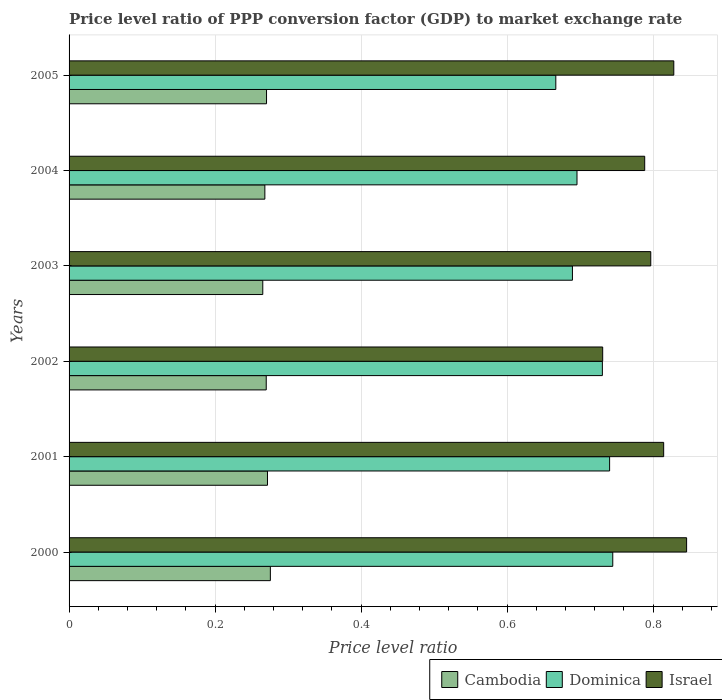How many groups of bars are there?
Ensure brevity in your answer.  6. Are the number of bars per tick equal to the number of legend labels?
Provide a succinct answer. Yes. Are the number of bars on each tick of the Y-axis equal?
Your response must be concise. Yes. How many bars are there on the 2nd tick from the top?
Provide a succinct answer. 3. How many bars are there on the 6th tick from the bottom?
Make the answer very short. 3. What is the price level ratio in Cambodia in 2000?
Provide a succinct answer. 0.28. Across all years, what is the maximum price level ratio in Dominica?
Offer a terse response. 0.74. Across all years, what is the minimum price level ratio in Cambodia?
Your answer should be compact. 0.27. In which year was the price level ratio in Cambodia minimum?
Your response must be concise. 2003. What is the total price level ratio in Dominica in the graph?
Keep it short and to the point. 4.27. What is the difference between the price level ratio in Dominica in 2001 and that in 2002?
Your answer should be very brief. 0.01. What is the difference between the price level ratio in Israel in 2001 and the price level ratio in Dominica in 2002?
Ensure brevity in your answer.  0.08. What is the average price level ratio in Israel per year?
Offer a very short reply. 0.8. In the year 2001, what is the difference between the price level ratio in Cambodia and price level ratio in Dominica?
Your answer should be compact. -0.47. In how many years, is the price level ratio in Israel greater than 0.56 ?
Make the answer very short. 6. What is the ratio of the price level ratio in Israel in 2001 to that in 2004?
Give a very brief answer. 1.03. What is the difference between the highest and the second highest price level ratio in Israel?
Give a very brief answer. 0.02. What is the difference between the highest and the lowest price level ratio in Israel?
Give a very brief answer. 0.11. In how many years, is the price level ratio in Israel greater than the average price level ratio in Israel taken over all years?
Your answer should be very brief. 3. Is it the case that in every year, the sum of the price level ratio in Israel and price level ratio in Cambodia is greater than the price level ratio in Dominica?
Your answer should be very brief. Yes. How many bars are there?
Your answer should be very brief. 18. Are all the bars in the graph horizontal?
Your response must be concise. Yes. How many years are there in the graph?
Offer a terse response. 6. What is the difference between two consecutive major ticks on the X-axis?
Your response must be concise. 0.2. Are the values on the major ticks of X-axis written in scientific E-notation?
Your answer should be very brief. No. Does the graph contain grids?
Keep it short and to the point. Yes. Where does the legend appear in the graph?
Offer a terse response. Bottom right. How many legend labels are there?
Ensure brevity in your answer.  3. What is the title of the graph?
Give a very brief answer. Price level ratio of PPP conversion factor (GDP) to market exchange rate. Does "Tunisia" appear as one of the legend labels in the graph?
Offer a terse response. No. What is the label or title of the X-axis?
Ensure brevity in your answer.  Price level ratio. What is the Price level ratio of Cambodia in 2000?
Keep it short and to the point. 0.28. What is the Price level ratio in Dominica in 2000?
Your response must be concise. 0.74. What is the Price level ratio in Israel in 2000?
Make the answer very short. 0.85. What is the Price level ratio of Cambodia in 2001?
Make the answer very short. 0.27. What is the Price level ratio of Dominica in 2001?
Provide a succinct answer. 0.74. What is the Price level ratio of Israel in 2001?
Make the answer very short. 0.81. What is the Price level ratio of Cambodia in 2002?
Your response must be concise. 0.27. What is the Price level ratio in Dominica in 2002?
Ensure brevity in your answer.  0.73. What is the Price level ratio of Israel in 2002?
Provide a short and direct response. 0.73. What is the Price level ratio in Cambodia in 2003?
Offer a terse response. 0.27. What is the Price level ratio in Dominica in 2003?
Ensure brevity in your answer.  0.69. What is the Price level ratio in Israel in 2003?
Provide a succinct answer. 0.8. What is the Price level ratio of Cambodia in 2004?
Offer a terse response. 0.27. What is the Price level ratio in Dominica in 2004?
Provide a succinct answer. 0.7. What is the Price level ratio in Israel in 2004?
Your response must be concise. 0.79. What is the Price level ratio of Cambodia in 2005?
Your answer should be compact. 0.27. What is the Price level ratio of Dominica in 2005?
Offer a very short reply. 0.67. What is the Price level ratio of Israel in 2005?
Your answer should be compact. 0.83. Across all years, what is the maximum Price level ratio in Cambodia?
Offer a very short reply. 0.28. Across all years, what is the maximum Price level ratio of Dominica?
Provide a succinct answer. 0.74. Across all years, what is the maximum Price level ratio in Israel?
Make the answer very short. 0.85. Across all years, what is the minimum Price level ratio in Cambodia?
Ensure brevity in your answer.  0.27. Across all years, what is the minimum Price level ratio in Dominica?
Provide a succinct answer. 0.67. Across all years, what is the minimum Price level ratio of Israel?
Keep it short and to the point. 0.73. What is the total Price level ratio in Cambodia in the graph?
Your response must be concise. 1.62. What is the total Price level ratio in Dominica in the graph?
Your answer should be compact. 4.27. What is the total Price level ratio in Israel in the graph?
Your answer should be compact. 4.8. What is the difference between the Price level ratio of Cambodia in 2000 and that in 2001?
Offer a terse response. 0. What is the difference between the Price level ratio of Dominica in 2000 and that in 2001?
Offer a very short reply. 0. What is the difference between the Price level ratio of Israel in 2000 and that in 2001?
Offer a very short reply. 0.03. What is the difference between the Price level ratio of Cambodia in 2000 and that in 2002?
Your answer should be compact. 0.01. What is the difference between the Price level ratio in Dominica in 2000 and that in 2002?
Make the answer very short. 0.01. What is the difference between the Price level ratio of Israel in 2000 and that in 2002?
Ensure brevity in your answer.  0.11. What is the difference between the Price level ratio of Cambodia in 2000 and that in 2003?
Your answer should be very brief. 0.01. What is the difference between the Price level ratio of Dominica in 2000 and that in 2003?
Provide a short and direct response. 0.06. What is the difference between the Price level ratio of Israel in 2000 and that in 2003?
Make the answer very short. 0.05. What is the difference between the Price level ratio of Cambodia in 2000 and that in 2004?
Offer a very short reply. 0.01. What is the difference between the Price level ratio of Dominica in 2000 and that in 2004?
Your answer should be very brief. 0.05. What is the difference between the Price level ratio of Israel in 2000 and that in 2004?
Provide a succinct answer. 0.06. What is the difference between the Price level ratio of Cambodia in 2000 and that in 2005?
Provide a short and direct response. 0.01. What is the difference between the Price level ratio of Dominica in 2000 and that in 2005?
Offer a terse response. 0.08. What is the difference between the Price level ratio of Israel in 2000 and that in 2005?
Give a very brief answer. 0.02. What is the difference between the Price level ratio in Cambodia in 2001 and that in 2002?
Your answer should be compact. 0. What is the difference between the Price level ratio of Dominica in 2001 and that in 2002?
Your answer should be compact. 0.01. What is the difference between the Price level ratio in Israel in 2001 and that in 2002?
Provide a succinct answer. 0.08. What is the difference between the Price level ratio in Cambodia in 2001 and that in 2003?
Your answer should be very brief. 0.01. What is the difference between the Price level ratio in Dominica in 2001 and that in 2003?
Your answer should be very brief. 0.05. What is the difference between the Price level ratio in Israel in 2001 and that in 2003?
Ensure brevity in your answer.  0.02. What is the difference between the Price level ratio of Cambodia in 2001 and that in 2004?
Offer a terse response. 0. What is the difference between the Price level ratio of Dominica in 2001 and that in 2004?
Keep it short and to the point. 0.04. What is the difference between the Price level ratio of Israel in 2001 and that in 2004?
Offer a very short reply. 0.03. What is the difference between the Price level ratio of Cambodia in 2001 and that in 2005?
Provide a succinct answer. 0. What is the difference between the Price level ratio in Dominica in 2001 and that in 2005?
Ensure brevity in your answer.  0.07. What is the difference between the Price level ratio in Israel in 2001 and that in 2005?
Keep it short and to the point. -0.01. What is the difference between the Price level ratio in Cambodia in 2002 and that in 2003?
Make the answer very short. 0. What is the difference between the Price level ratio in Dominica in 2002 and that in 2003?
Provide a succinct answer. 0.04. What is the difference between the Price level ratio in Israel in 2002 and that in 2003?
Ensure brevity in your answer.  -0.07. What is the difference between the Price level ratio in Cambodia in 2002 and that in 2004?
Provide a short and direct response. 0. What is the difference between the Price level ratio of Dominica in 2002 and that in 2004?
Provide a short and direct response. 0.03. What is the difference between the Price level ratio of Israel in 2002 and that in 2004?
Ensure brevity in your answer.  -0.06. What is the difference between the Price level ratio of Cambodia in 2002 and that in 2005?
Make the answer very short. -0. What is the difference between the Price level ratio of Dominica in 2002 and that in 2005?
Your answer should be compact. 0.06. What is the difference between the Price level ratio in Israel in 2002 and that in 2005?
Your answer should be compact. -0.1. What is the difference between the Price level ratio in Cambodia in 2003 and that in 2004?
Your answer should be compact. -0. What is the difference between the Price level ratio in Dominica in 2003 and that in 2004?
Offer a terse response. -0.01. What is the difference between the Price level ratio in Israel in 2003 and that in 2004?
Your answer should be very brief. 0.01. What is the difference between the Price level ratio of Cambodia in 2003 and that in 2005?
Your answer should be compact. -0.01. What is the difference between the Price level ratio in Dominica in 2003 and that in 2005?
Your answer should be very brief. 0.02. What is the difference between the Price level ratio in Israel in 2003 and that in 2005?
Make the answer very short. -0.03. What is the difference between the Price level ratio of Cambodia in 2004 and that in 2005?
Provide a succinct answer. -0. What is the difference between the Price level ratio of Dominica in 2004 and that in 2005?
Provide a succinct answer. 0.03. What is the difference between the Price level ratio of Israel in 2004 and that in 2005?
Keep it short and to the point. -0.04. What is the difference between the Price level ratio in Cambodia in 2000 and the Price level ratio in Dominica in 2001?
Provide a short and direct response. -0.46. What is the difference between the Price level ratio in Cambodia in 2000 and the Price level ratio in Israel in 2001?
Provide a succinct answer. -0.54. What is the difference between the Price level ratio of Dominica in 2000 and the Price level ratio of Israel in 2001?
Keep it short and to the point. -0.07. What is the difference between the Price level ratio in Cambodia in 2000 and the Price level ratio in Dominica in 2002?
Your response must be concise. -0.45. What is the difference between the Price level ratio of Cambodia in 2000 and the Price level ratio of Israel in 2002?
Ensure brevity in your answer.  -0.46. What is the difference between the Price level ratio in Dominica in 2000 and the Price level ratio in Israel in 2002?
Provide a short and direct response. 0.01. What is the difference between the Price level ratio of Cambodia in 2000 and the Price level ratio of Dominica in 2003?
Make the answer very short. -0.41. What is the difference between the Price level ratio in Cambodia in 2000 and the Price level ratio in Israel in 2003?
Your response must be concise. -0.52. What is the difference between the Price level ratio of Dominica in 2000 and the Price level ratio of Israel in 2003?
Your response must be concise. -0.05. What is the difference between the Price level ratio of Cambodia in 2000 and the Price level ratio of Dominica in 2004?
Give a very brief answer. -0.42. What is the difference between the Price level ratio of Cambodia in 2000 and the Price level ratio of Israel in 2004?
Provide a succinct answer. -0.51. What is the difference between the Price level ratio in Dominica in 2000 and the Price level ratio in Israel in 2004?
Provide a short and direct response. -0.04. What is the difference between the Price level ratio in Cambodia in 2000 and the Price level ratio in Dominica in 2005?
Provide a succinct answer. -0.39. What is the difference between the Price level ratio in Cambodia in 2000 and the Price level ratio in Israel in 2005?
Your response must be concise. -0.55. What is the difference between the Price level ratio in Dominica in 2000 and the Price level ratio in Israel in 2005?
Offer a terse response. -0.08. What is the difference between the Price level ratio in Cambodia in 2001 and the Price level ratio in Dominica in 2002?
Give a very brief answer. -0.46. What is the difference between the Price level ratio of Cambodia in 2001 and the Price level ratio of Israel in 2002?
Provide a succinct answer. -0.46. What is the difference between the Price level ratio in Dominica in 2001 and the Price level ratio in Israel in 2002?
Provide a succinct answer. 0.01. What is the difference between the Price level ratio of Cambodia in 2001 and the Price level ratio of Dominica in 2003?
Give a very brief answer. -0.42. What is the difference between the Price level ratio of Cambodia in 2001 and the Price level ratio of Israel in 2003?
Ensure brevity in your answer.  -0.52. What is the difference between the Price level ratio in Dominica in 2001 and the Price level ratio in Israel in 2003?
Make the answer very short. -0.06. What is the difference between the Price level ratio of Cambodia in 2001 and the Price level ratio of Dominica in 2004?
Your response must be concise. -0.42. What is the difference between the Price level ratio in Cambodia in 2001 and the Price level ratio in Israel in 2004?
Ensure brevity in your answer.  -0.52. What is the difference between the Price level ratio of Dominica in 2001 and the Price level ratio of Israel in 2004?
Offer a very short reply. -0.05. What is the difference between the Price level ratio in Cambodia in 2001 and the Price level ratio in Dominica in 2005?
Ensure brevity in your answer.  -0.39. What is the difference between the Price level ratio of Cambodia in 2001 and the Price level ratio of Israel in 2005?
Offer a very short reply. -0.56. What is the difference between the Price level ratio in Dominica in 2001 and the Price level ratio in Israel in 2005?
Provide a short and direct response. -0.09. What is the difference between the Price level ratio in Cambodia in 2002 and the Price level ratio in Dominica in 2003?
Offer a terse response. -0.42. What is the difference between the Price level ratio in Cambodia in 2002 and the Price level ratio in Israel in 2003?
Give a very brief answer. -0.53. What is the difference between the Price level ratio in Dominica in 2002 and the Price level ratio in Israel in 2003?
Provide a succinct answer. -0.07. What is the difference between the Price level ratio in Cambodia in 2002 and the Price level ratio in Dominica in 2004?
Keep it short and to the point. -0.43. What is the difference between the Price level ratio of Cambodia in 2002 and the Price level ratio of Israel in 2004?
Give a very brief answer. -0.52. What is the difference between the Price level ratio of Dominica in 2002 and the Price level ratio of Israel in 2004?
Offer a terse response. -0.06. What is the difference between the Price level ratio in Cambodia in 2002 and the Price level ratio in Dominica in 2005?
Keep it short and to the point. -0.4. What is the difference between the Price level ratio of Cambodia in 2002 and the Price level ratio of Israel in 2005?
Ensure brevity in your answer.  -0.56. What is the difference between the Price level ratio of Dominica in 2002 and the Price level ratio of Israel in 2005?
Ensure brevity in your answer.  -0.1. What is the difference between the Price level ratio of Cambodia in 2003 and the Price level ratio of Dominica in 2004?
Make the answer very short. -0.43. What is the difference between the Price level ratio in Cambodia in 2003 and the Price level ratio in Israel in 2004?
Your answer should be very brief. -0.52. What is the difference between the Price level ratio in Dominica in 2003 and the Price level ratio in Israel in 2004?
Provide a succinct answer. -0.1. What is the difference between the Price level ratio of Cambodia in 2003 and the Price level ratio of Dominica in 2005?
Offer a terse response. -0.4. What is the difference between the Price level ratio in Cambodia in 2003 and the Price level ratio in Israel in 2005?
Keep it short and to the point. -0.56. What is the difference between the Price level ratio in Dominica in 2003 and the Price level ratio in Israel in 2005?
Make the answer very short. -0.14. What is the difference between the Price level ratio in Cambodia in 2004 and the Price level ratio in Dominica in 2005?
Offer a terse response. -0.4. What is the difference between the Price level ratio in Cambodia in 2004 and the Price level ratio in Israel in 2005?
Offer a terse response. -0.56. What is the difference between the Price level ratio of Dominica in 2004 and the Price level ratio of Israel in 2005?
Provide a succinct answer. -0.13. What is the average Price level ratio in Cambodia per year?
Your answer should be very brief. 0.27. What is the average Price level ratio of Dominica per year?
Make the answer very short. 0.71. What is the average Price level ratio of Israel per year?
Keep it short and to the point. 0.8. In the year 2000, what is the difference between the Price level ratio in Cambodia and Price level ratio in Dominica?
Offer a very short reply. -0.47. In the year 2000, what is the difference between the Price level ratio in Cambodia and Price level ratio in Israel?
Make the answer very short. -0.57. In the year 2000, what is the difference between the Price level ratio of Dominica and Price level ratio of Israel?
Provide a short and direct response. -0.1. In the year 2001, what is the difference between the Price level ratio of Cambodia and Price level ratio of Dominica?
Give a very brief answer. -0.47. In the year 2001, what is the difference between the Price level ratio of Cambodia and Price level ratio of Israel?
Your answer should be compact. -0.54. In the year 2001, what is the difference between the Price level ratio in Dominica and Price level ratio in Israel?
Offer a terse response. -0.07. In the year 2002, what is the difference between the Price level ratio of Cambodia and Price level ratio of Dominica?
Your answer should be compact. -0.46. In the year 2002, what is the difference between the Price level ratio of Cambodia and Price level ratio of Israel?
Ensure brevity in your answer.  -0.46. In the year 2002, what is the difference between the Price level ratio of Dominica and Price level ratio of Israel?
Offer a very short reply. -0. In the year 2003, what is the difference between the Price level ratio in Cambodia and Price level ratio in Dominica?
Ensure brevity in your answer.  -0.42. In the year 2003, what is the difference between the Price level ratio of Cambodia and Price level ratio of Israel?
Your response must be concise. -0.53. In the year 2003, what is the difference between the Price level ratio in Dominica and Price level ratio in Israel?
Make the answer very short. -0.11. In the year 2004, what is the difference between the Price level ratio in Cambodia and Price level ratio in Dominica?
Ensure brevity in your answer.  -0.43. In the year 2004, what is the difference between the Price level ratio in Cambodia and Price level ratio in Israel?
Make the answer very short. -0.52. In the year 2004, what is the difference between the Price level ratio of Dominica and Price level ratio of Israel?
Keep it short and to the point. -0.09. In the year 2005, what is the difference between the Price level ratio of Cambodia and Price level ratio of Dominica?
Provide a short and direct response. -0.4. In the year 2005, what is the difference between the Price level ratio of Cambodia and Price level ratio of Israel?
Make the answer very short. -0.56. In the year 2005, what is the difference between the Price level ratio of Dominica and Price level ratio of Israel?
Your response must be concise. -0.16. What is the ratio of the Price level ratio of Cambodia in 2000 to that in 2001?
Your answer should be very brief. 1.01. What is the ratio of the Price level ratio in Dominica in 2000 to that in 2001?
Offer a terse response. 1.01. What is the ratio of the Price level ratio in Israel in 2000 to that in 2001?
Provide a succinct answer. 1.04. What is the ratio of the Price level ratio of Cambodia in 2000 to that in 2002?
Provide a short and direct response. 1.02. What is the ratio of the Price level ratio in Dominica in 2000 to that in 2002?
Keep it short and to the point. 1.02. What is the ratio of the Price level ratio of Israel in 2000 to that in 2002?
Your response must be concise. 1.16. What is the ratio of the Price level ratio of Cambodia in 2000 to that in 2003?
Provide a succinct answer. 1.04. What is the ratio of the Price level ratio of Dominica in 2000 to that in 2003?
Make the answer very short. 1.08. What is the ratio of the Price level ratio in Israel in 2000 to that in 2003?
Your response must be concise. 1.06. What is the ratio of the Price level ratio of Cambodia in 2000 to that in 2004?
Make the answer very short. 1.03. What is the ratio of the Price level ratio of Dominica in 2000 to that in 2004?
Make the answer very short. 1.07. What is the ratio of the Price level ratio in Israel in 2000 to that in 2004?
Provide a succinct answer. 1.07. What is the ratio of the Price level ratio in Cambodia in 2000 to that in 2005?
Provide a short and direct response. 1.02. What is the ratio of the Price level ratio in Dominica in 2000 to that in 2005?
Your answer should be compact. 1.12. What is the ratio of the Price level ratio in Israel in 2000 to that in 2005?
Offer a very short reply. 1.02. What is the ratio of the Price level ratio of Cambodia in 2001 to that in 2002?
Your response must be concise. 1.01. What is the ratio of the Price level ratio in Dominica in 2001 to that in 2002?
Ensure brevity in your answer.  1.01. What is the ratio of the Price level ratio in Israel in 2001 to that in 2002?
Keep it short and to the point. 1.11. What is the ratio of the Price level ratio in Cambodia in 2001 to that in 2003?
Keep it short and to the point. 1.02. What is the ratio of the Price level ratio of Dominica in 2001 to that in 2003?
Give a very brief answer. 1.07. What is the ratio of the Price level ratio in Israel in 2001 to that in 2003?
Make the answer very short. 1.02. What is the ratio of the Price level ratio in Cambodia in 2001 to that in 2004?
Your response must be concise. 1.01. What is the ratio of the Price level ratio of Dominica in 2001 to that in 2004?
Your response must be concise. 1.06. What is the ratio of the Price level ratio in Israel in 2001 to that in 2004?
Offer a terse response. 1.03. What is the ratio of the Price level ratio in Dominica in 2001 to that in 2005?
Offer a very short reply. 1.11. What is the ratio of the Price level ratio in Israel in 2001 to that in 2005?
Your answer should be very brief. 0.98. What is the ratio of the Price level ratio in Cambodia in 2002 to that in 2003?
Give a very brief answer. 1.02. What is the ratio of the Price level ratio in Dominica in 2002 to that in 2003?
Your answer should be compact. 1.06. What is the ratio of the Price level ratio in Israel in 2002 to that in 2003?
Your answer should be very brief. 0.92. What is the ratio of the Price level ratio in Cambodia in 2002 to that in 2004?
Your answer should be compact. 1.01. What is the ratio of the Price level ratio of Dominica in 2002 to that in 2004?
Your response must be concise. 1.05. What is the ratio of the Price level ratio in Israel in 2002 to that in 2004?
Give a very brief answer. 0.93. What is the ratio of the Price level ratio in Dominica in 2002 to that in 2005?
Ensure brevity in your answer.  1.1. What is the ratio of the Price level ratio in Israel in 2002 to that in 2005?
Your answer should be very brief. 0.88. What is the ratio of the Price level ratio in Israel in 2003 to that in 2004?
Keep it short and to the point. 1.01. What is the ratio of the Price level ratio of Cambodia in 2003 to that in 2005?
Give a very brief answer. 0.98. What is the ratio of the Price level ratio in Dominica in 2003 to that in 2005?
Your answer should be very brief. 1.03. What is the ratio of the Price level ratio of Israel in 2003 to that in 2005?
Give a very brief answer. 0.96. What is the ratio of the Price level ratio in Cambodia in 2004 to that in 2005?
Ensure brevity in your answer.  0.99. What is the ratio of the Price level ratio in Dominica in 2004 to that in 2005?
Your answer should be compact. 1.04. What is the ratio of the Price level ratio of Israel in 2004 to that in 2005?
Give a very brief answer. 0.95. What is the difference between the highest and the second highest Price level ratio of Cambodia?
Provide a short and direct response. 0. What is the difference between the highest and the second highest Price level ratio in Dominica?
Make the answer very short. 0. What is the difference between the highest and the second highest Price level ratio in Israel?
Offer a terse response. 0.02. What is the difference between the highest and the lowest Price level ratio in Cambodia?
Ensure brevity in your answer.  0.01. What is the difference between the highest and the lowest Price level ratio of Dominica?
Offer a very short reply. 0.08. What is the difference between the highest and the lowest Price level ratio in Israel?
Offer a terse response. 0.11. 